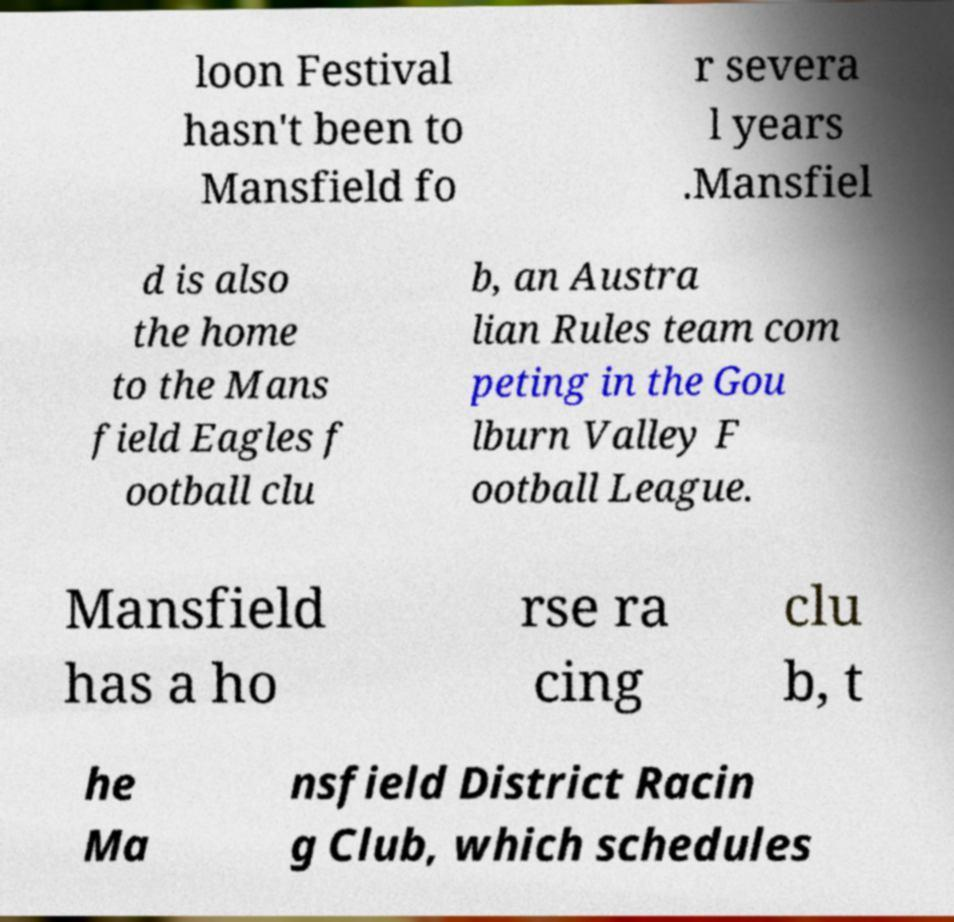Can you accurately transcribe the text from the provided image for me? loon Festival hasn't been to Mansfield fo r severa l years .Mansfiel d is also the home to the Mans field Eagles f ootball clu b, an Austra lian Rules team com peting in the Gou lburn Valley F ootball League. Mansfield has a ho rse ra cing clu b, t he Ma nsfield District Racin g Club, which schedules 